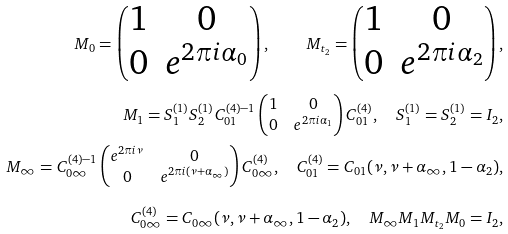Convert formula to latex. <formula><loc_0><loc_0><loc_500><loc_500>M _ { 0 } = \left ( \begin{matrix} 1 & 0 \\ 0 & e ^ { 2 \pi i \alpha _ { 0 } } \end{matrix} \right ) , \quad M _ { t _ { 2 } } = \left ( \begin{matrix} 1 & 0 \\ 0 & e ^ { 2 \pi i \alpha _ { 2 } } \end{matrix} \right ) , \\ M _ { 1 } = S _ { 1 } ^ { ( 1 ) } S _ { 2 } ^ { ( 1 ) } C _ { 0 1 } ^ { ( 4 ) - 1 } \left ( \begin{matrix} 1 & 0 \\ 0 & e ^ { 2 \pi i \alpha _ { 1 } } \end{matrix} \right ) C _ { 0 1 } ^ { ( 4 ) } , \quad S _ { 1 } ^ { ( 1 ) } = S _ { 2 } ^ { ( 1 ) } = I _ { 2 } , \\ M _ { \infty } = C _ { 0 \infty } ^ { ( 4 ) - 1 } \left ( \begin{matrix} e ^ { 2 \pi i \nu } & 0 \\ 0 & e ^ { 2 \pi i ( \nu + \alpha _ { \infty } ) } \end{matrix} \right ) C _ { 0 \infty } ^ { ( 4 ) } , \quad C _ { 0 1 } ^ { ( 4 ) } = C _ { 0 1 } ( \nu , \nu + \alpha _ { \infty } , 1 - \alpha _ { 2 } ) , \\ C _ { 0 \infty } ^ { ( 4 ) } = C _ { 0 \infty } ( \nu , \nu + \alpha _ { \infty } , 1 - \alpha _ { 2 } ) , \quad M _ { \infty } M _ { 1 } M _ { t _ { 2 } } M _ { 0 } = I _ { 2 } ,</formula> 